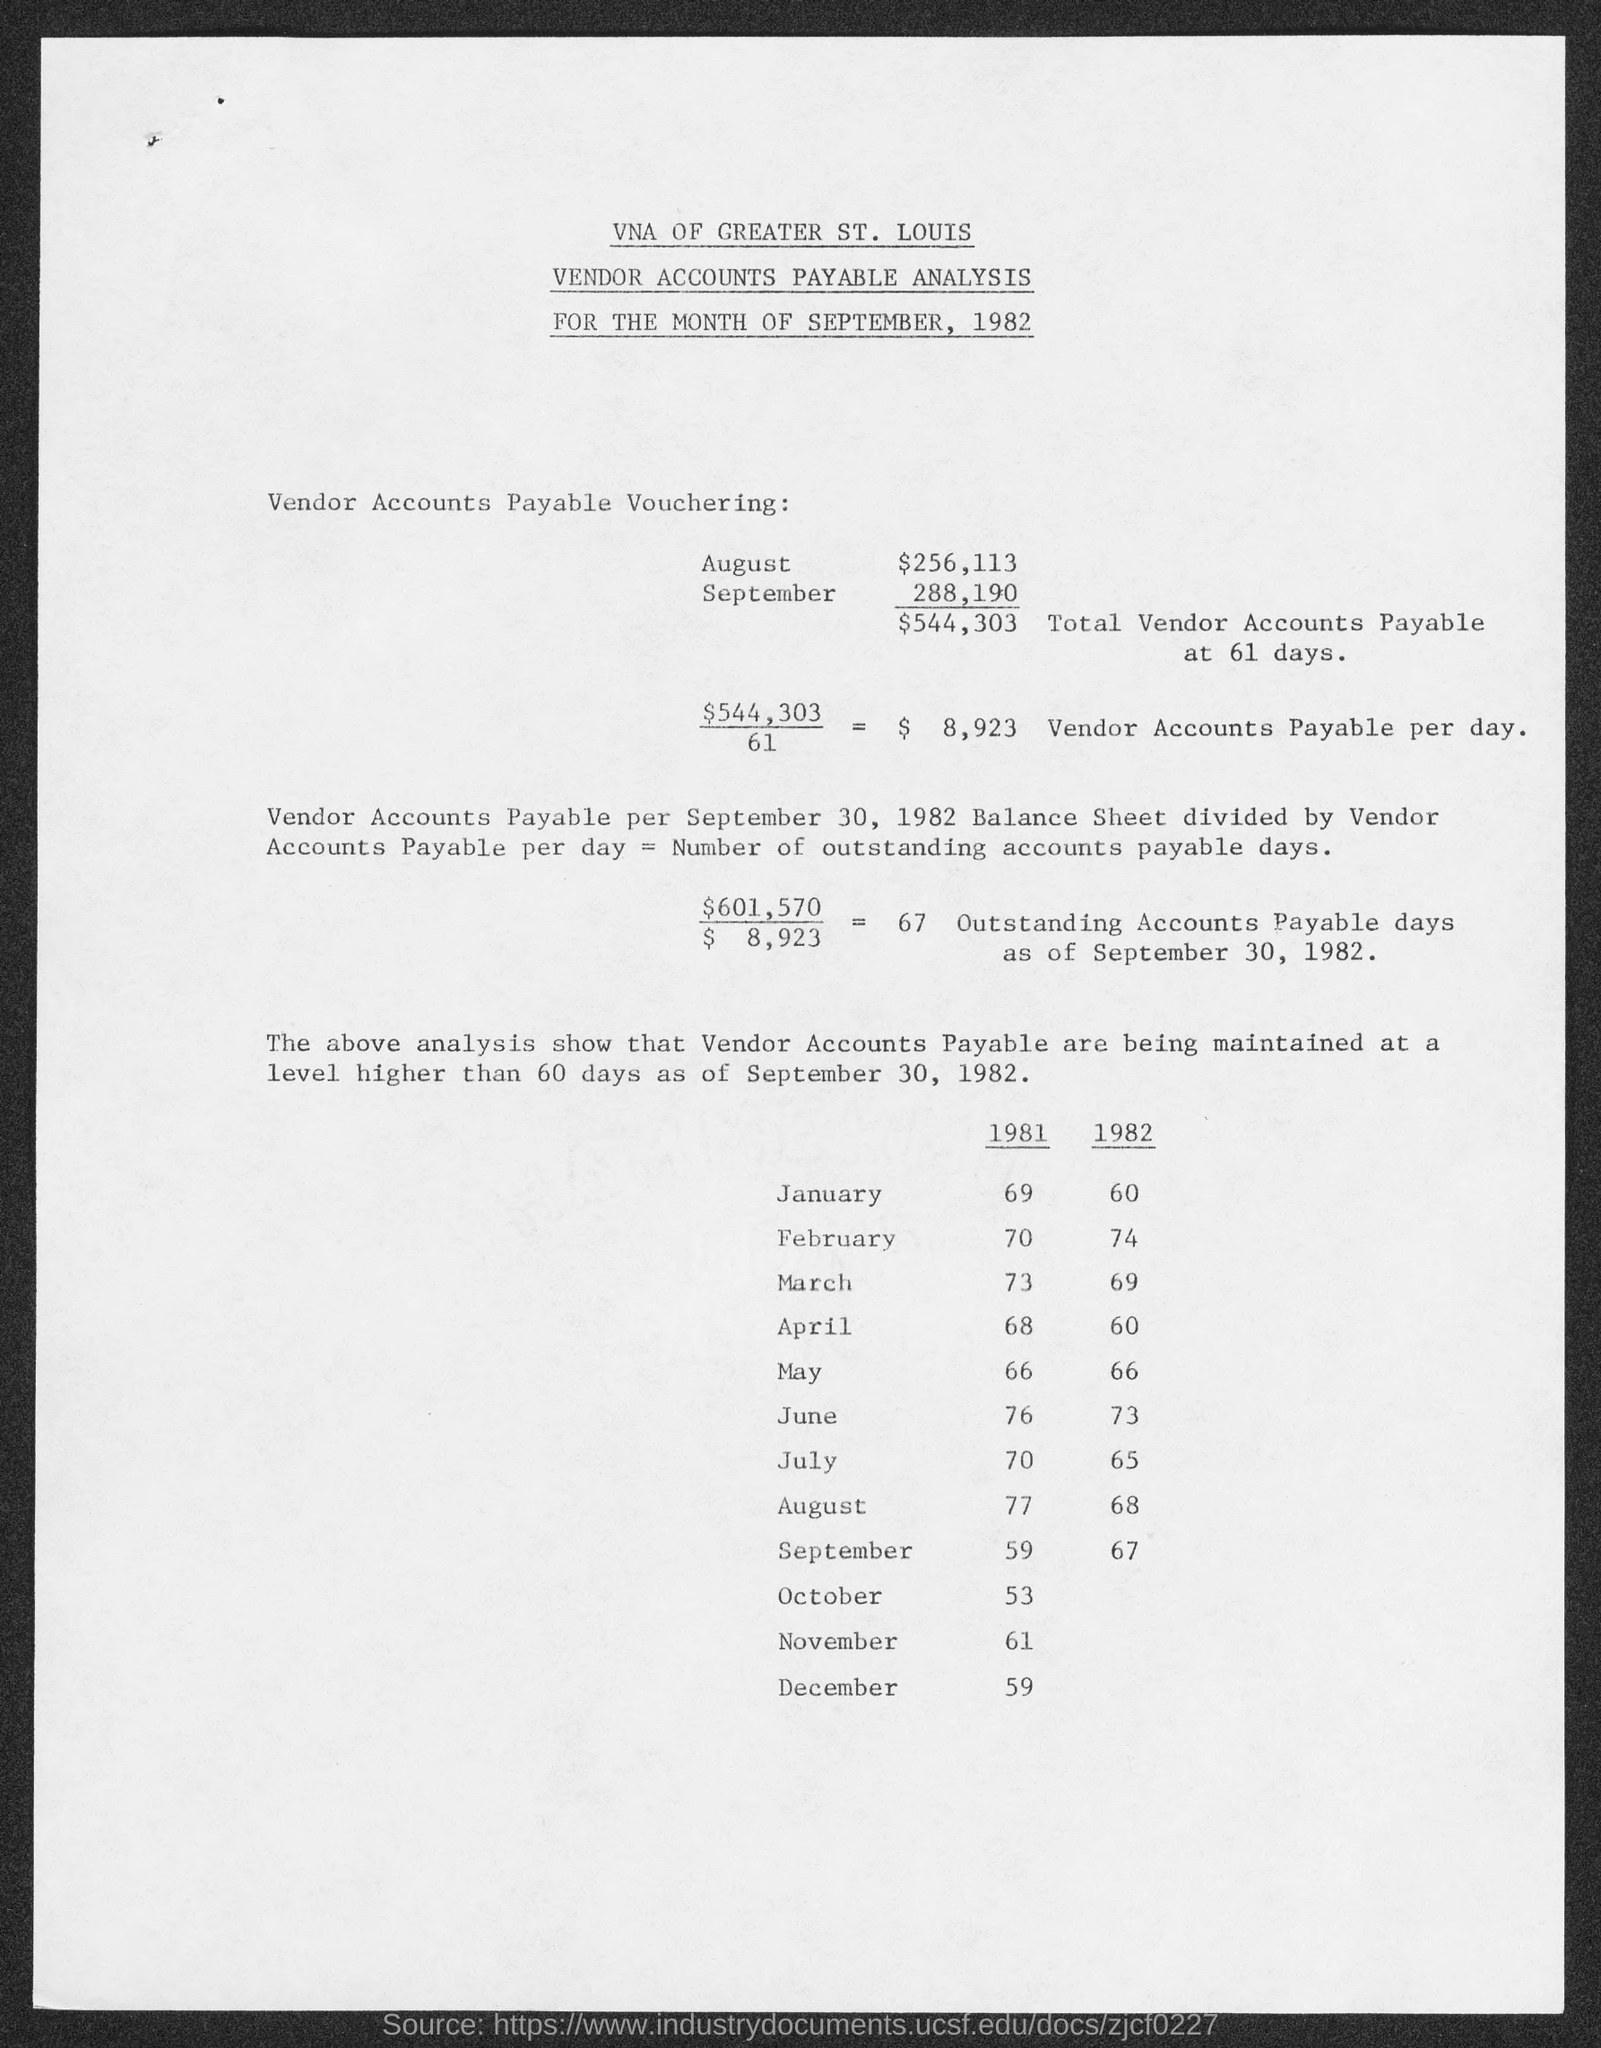What is the amount for august mentioned in the given page ?
Make the answer very short. $ 256,113. What is the amount for september mentioned in the given page ?
Give a very brief answer. 288,190. What is the amount of total vendor accounts payable at 61 days as mentioned in the given page ?
Your answer should be very brief. $ 544,303. What is the amount that vendor accounts payable per day as mentioned in the given page ?
Provide a succinct answer. $8,923. What are the outstanding accounts payable days as of september 30, 1982 ?
Your response must be concise. 67. 